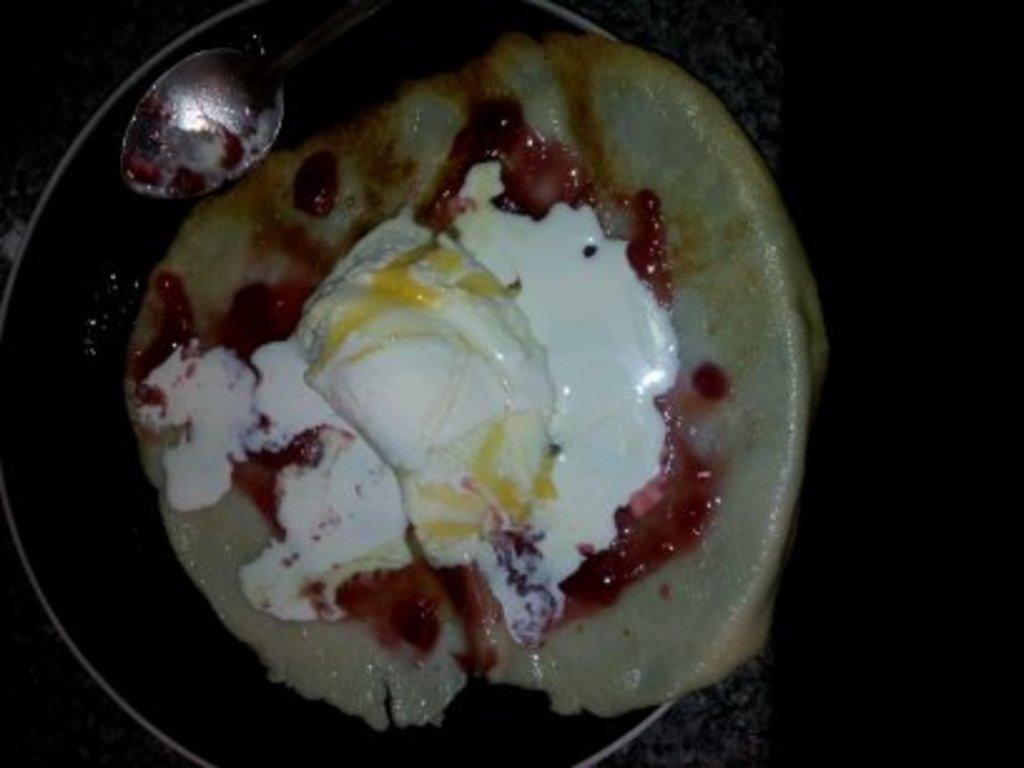Can you describe this image briefly? In this picture there is food and spoon in the bowl. At the bottom it looks like a marble. On the right side of the image there is a black background. 